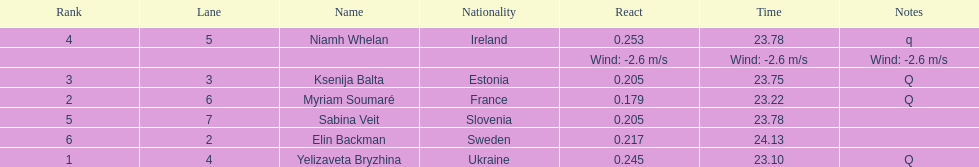Which player is from ireland? Niamh Whelan. 